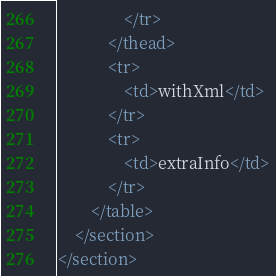<code> <loc_0><loc_0><loc_500><loc_500><_XML_>                </tr>
            </thead>
            <tr>
                <td>withXml</td>
            </tr>
            <tr>
                <td>extraInfo</td>
            </tr>
        </table>
    </section>
</section></code> 